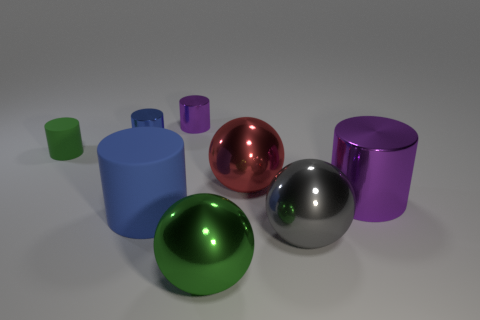Subtract 1 cylinders. How many cylinders are left? 4 Subtract all blue metallic cylinders. How many cylinders are left? 4 Subtract all green cylinders. How many cylinders are left? 4 Subtract all gray cylinders. Subtract all brown cubes. How many cylinders are left? 5 Add 1 big matte balls. How many objects exist? 9 Subtract all balls. How many objects are left? 5 Add 1 tiny red rubber cubes. How many tiny red rubber cubes exist? 1 Subtract 1 gray balls. How many objects are left? 7 Subtract all gray balls. Subtract all large red metal balls. How many objects are left? 6 Add 7 big blue cylinders. How many big blue cylinders are left? 8 